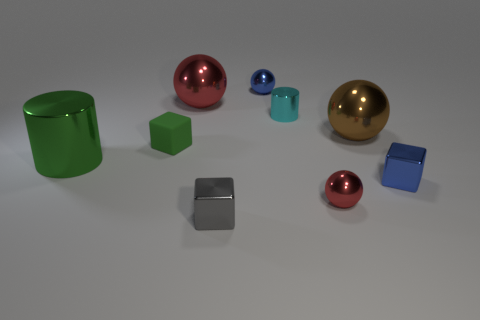Subtract all large red metal balls. How many balls are left? 3 Subtract all blue cubes. How many red balls are left? 2 Subtract all brown spheres. How many spheres are left? 3 Subtract 1 blocks. How many blocks are left? 2 Subtract all cylinders. How many objects are left? 7 Subtract all blue spheres. Subtract all yellow cylinders. How many spheres are left? 3 Subtract all small blue metal objects. Subtract all purple things. How many objects are left? 7 Add 7 blue metal objects. How many blue metal objects are left? 9 Add 5 purple matte blocks. How many purple matte blocks exist? 5 Subtract 1 blue blocks. How many objects are left? 8 